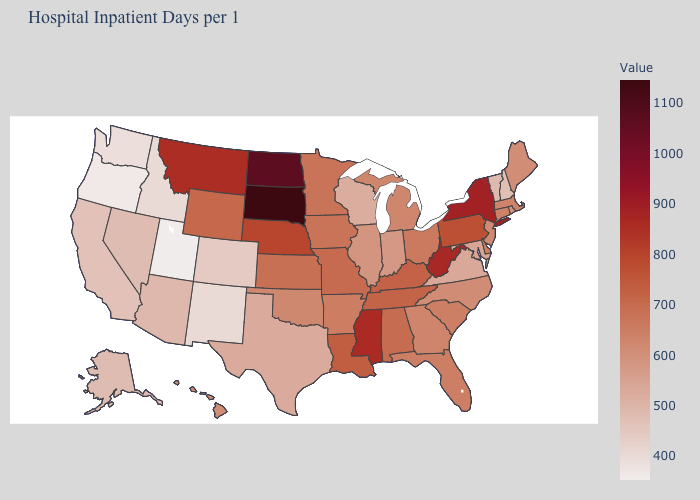Which states have the lowest value in the South?
Keep it brief. Texas. Does the map have missing data?
Give a very brief answer. No. Among the states that border Washington , which have the highest value?
Answer briefly. Idaho. Among the states that border Rhode Island , does Massachusetts have the highest value?
Quick response, please. No. Does Utah have the lowest value in the West?
Concise answer only. Yes. Does the map have missing data?
Be succinct. No. Which states have the highest value in the USA?
Answer briefly. South Dakota. 